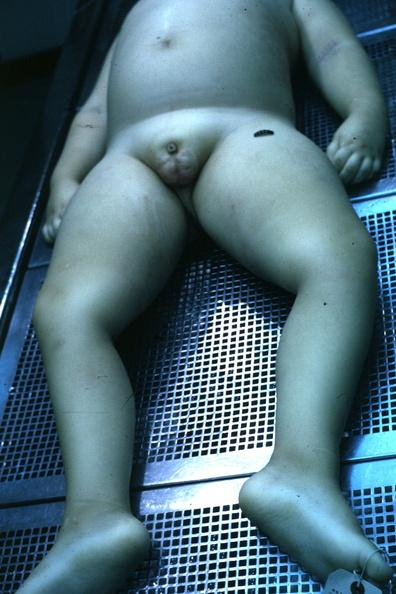what is present?
Answer the question using a single word or phrase. Penis 